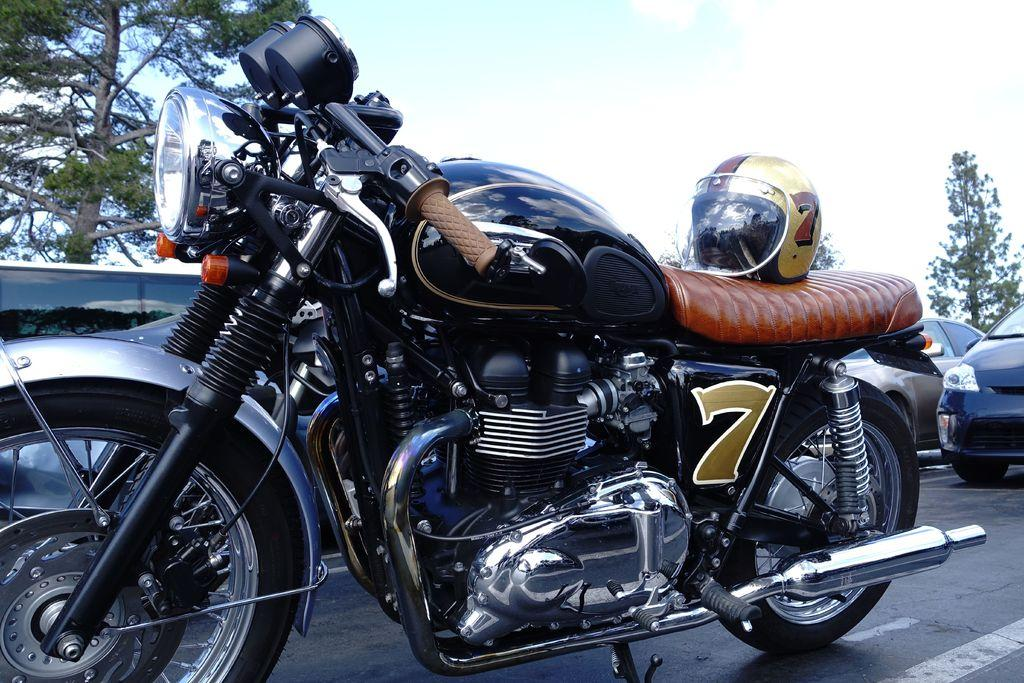What is the main subject in the center of the image? There is a bike in the center of the image. What safety accessory is on the bike? A helmet is on the bike. What can be seen in the background of the image? There are cars, trees, and the sky visible in the background of the image. What type of surface is at the bottom of the image? There is a road at the bottom of the image. How does the bike attract the attention of passersby in the image? The bike does not attract attention in the image; it is just a static object. 